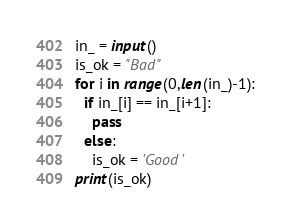Convert code to text. <code><loc_0><loc_0><loc_500><loc_500><_Python_>in_ = input()
is_ok = "Bad"
for i in range(0,len(in_)-1):
  if in_[i] == in_[i+1]:
    pass
  else:
    is_ok = 'Good'
print(is_ok)
</code> 